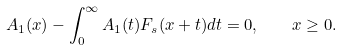Convert formula to latex. <formula><loc_0><loc_0><loc_500><loc_500>A _ { 1 } ( x ) - \int ^ { \infty } _ { 0 } A _ { 1 } ( t ) F _ { s } ( x + t ) d t = 0 , \quad x \geq 0 .</formula> 